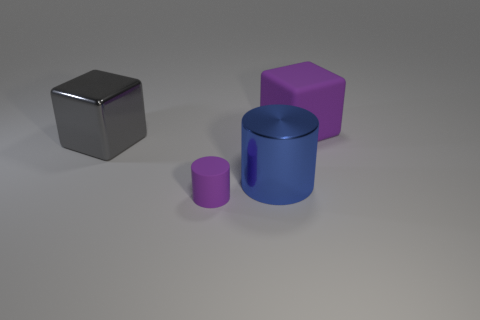Add 2 small brown cylinders. How many objects exist? 6 Subtract all small purple cylinders. Subtract all large shiny blocks. How many objects are left? 2 Add 2 big rubber cubes. How many big rubber cubes are left? 3 Add 1 large shiny cylinders. How many large shiny cylinders exist? 2 Subtract 1 purple blocks. How many objects are left? 3 